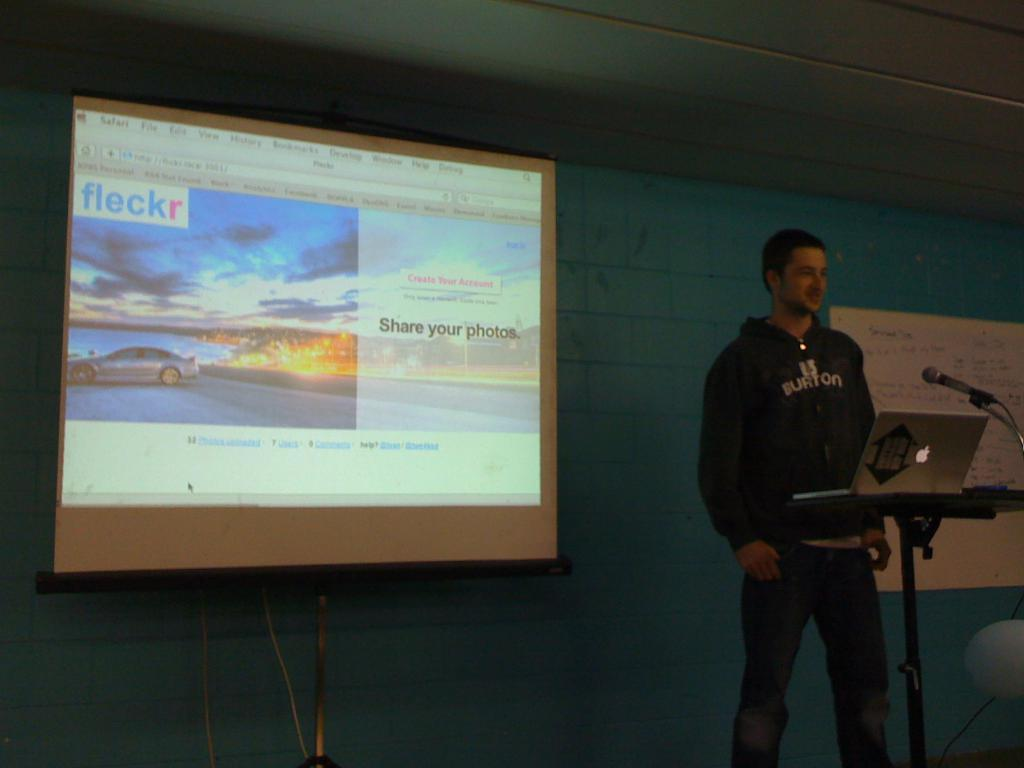<image>
Relay a brief, clear account of the picture shown. A man giving a Fleckr presentation about Share your photos. 